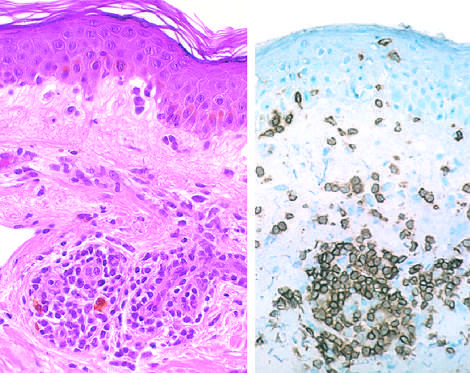does failure to stain reveal a predominantly perivascular cellular infiltrate that marks positively with anti-cd4 antibodies?
Answer the question using a single word or phrase. No 